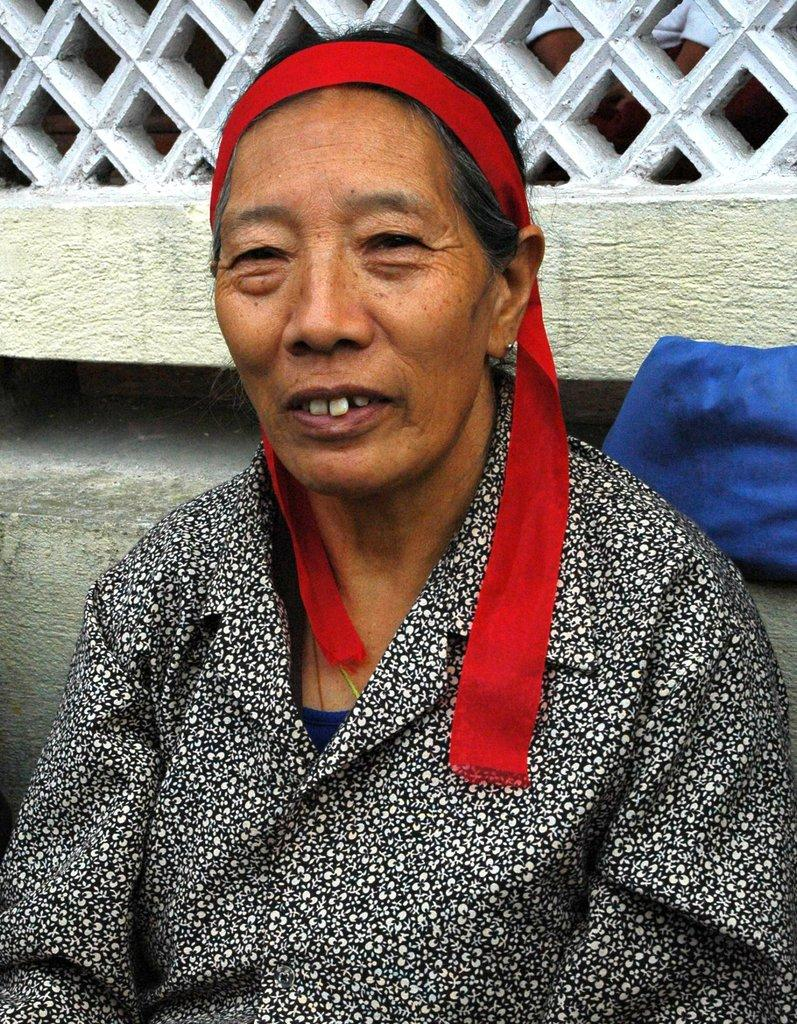What is the main subject of the image? There is a woman sitting in the center of the image. What is the woman wearing in the image? The woman is wearing a black shirt. What can be seen in the background of the image? There is a wall in the background of the image. What type of badge is the woman wearing in the image? There is no badge visible on the woman in the image. What position does the woman hold, as indicated by her attire in the image? The image does not provide any information about the woman's position or occupation. 